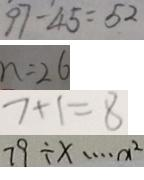Convert formula to latex. <formula><loc_0><loc_0><loc_500><loc_500>9 7 - 4 5 = 5 2 
 n = 2 6 
 7 + 1 = 8 
 7 9 \div x \cdots x ^ { 2 }</formula> 